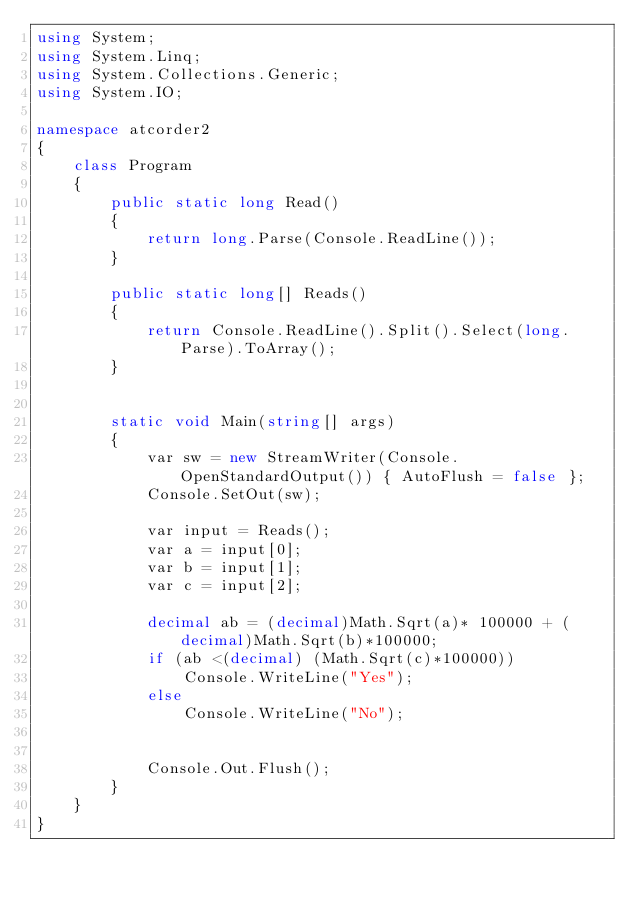<code> <loc_0><loc_0><loc_500><loc_500><_C#_>using System;
using System.Linq;
using System.Collections.Generic;
using System.IO;

namespace atcorder2
{
    class Program
    {
        public static long Read()
        {
            return long.Parse(Console.ReadLine());
        }

        public static long[] Reads()
        {
            return Console.ReadLine().Split().Select(long.Parse).ToArray();
        }


        static void Main(string[] args)
        {
            var sw = new StreamWriter(Console.OpenStandardOutput()) { AutoFlush = false };
            Console.SetOut(sw);

            var input = Reads();
            var a = input[0];
            var b = input[1];
            var c = input[2];
           
            decimal ab = (decimal)Math.Sqrt(a)* 100000 + (decimal)Math.Sqrt(b)*100000;
            if (ab <(decimal) (Math.Sqrt(c)*100000))
                Console.WriteLine("Yes");
            else
                Console.WriteLine("No");


            Console.Out.Flush();
        }
    }
}</code> 